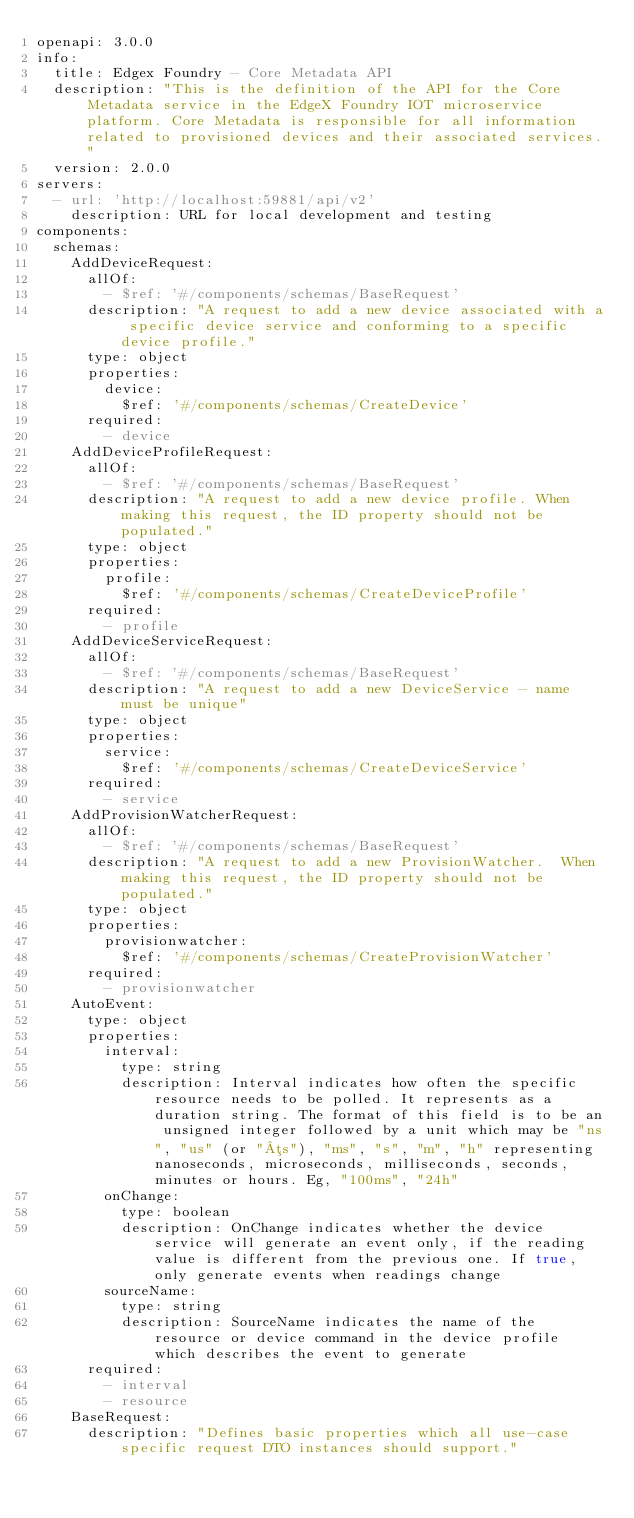Convert code to text. <code><loc_0><loc_0><loc_500><loc_500><_YAML_>openapi: 3.0.0
info:
  title: Edgex Foundry - Core Metadata API
  description: "This is the definition of the API for the Core Metadata service in the EdgeX Foundry IOT microservice platform. Core Metadata is responsible for all information related to provisioned devices and their associated services."
  version: 2.0.0
servers:
  - url: 'http://localhost:59881/api/v2'
    description: URL for local development and testing
components:
  schemas:
    AddDeviceRequest:
      allOf:
        - $ref: '#/components/schemas/BaseRequest'
      description: "A request to add a new device associated with a specific device service and conforming to a specific device profile."
      type: object
      properties:
        device:
          $ref: '#/components/schemas/CreateDevice'
      required:
        - device
    AddDeviceProfileRequest:
      allOf:
        - $ref: '#/components/schemas/BaseRequest'
      description: "A request to add a new device profile. When making this request, the ID property should not be populated."
      type: object
      properties:
        profile:
          $ref: '#/components/schemas/CreateDeviceProfile'
      required:
        - profile
    AddDeviceServiceRequest:
      allOf:
        - $ref: '#/components/schemas/BaseRequest'
      description: "A request to add a new DeviceService - name must be unique"
      type: object
      properties:
        service:
          $ref: '#/components/schemas/CreateDeviceService'
      required:
        - service
    AddProvisionWatcherRequest:
      allOf:
        - $ref: '#/components/schemas/BaseRequest'
      description: "A request to add a new ProvisionWatcher.  When making this request, the ID property should not be populated."
      type: object
      properties:
        provisionwatcher:
          $ref: '#/components/schemas/CreateProvisionWatcher'
      required:
        - provisionwatcher
    AutoEvent:
      type: object
      properties:
        interval:
          type: string
          description: Interval indicates how often the specific resource needs to be polled. It represents as a duration string. The format of this field is to be an unsigned integer followed by a unit which may be "ns", "us" (or "µs"), "ms", "s", "m", "h" representing nanoseconds, microseconds, milliseconds, seconds, minutes or hours. Eg, "100ms", "24h"
        onChange:
          type: boolean
          description: OnChange indicates whether the device service will generate an event only, if the reading value is different from the previous one. If true, only generate events when readings change
        sourceName:
          type: string
          description: SourceName indicates the name of the resource or device command in the device profile which describes the event to generate
      required:
        - interval
        - resource
    BaseRequest:
      description: "Defines basic properties which all use-case specific request DTO instances should support."</code> 